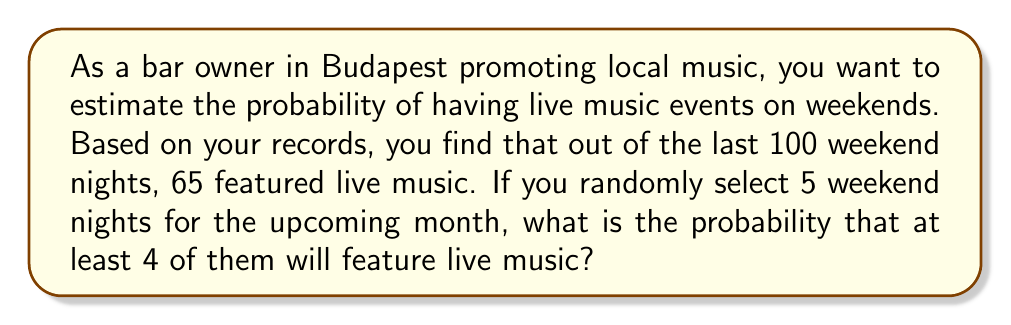What is the answer to this math problem? To solve this problem, we'll use the binomial probability distribution.

1. First, let's identify the components:
   - $n$ (number of trials) = 5 weekend nights
   - $p$ (probability of success) = 65/100 = 0.65
   - $q$ (probability of failure) = 1 - p = 0.35
   - We want the probability of at least 4 successes, so we'll calculate P(X ≥ 4)

2. The binomial probability formula is:

   $$P(X = k) = \binom{n}{k} p^k q^{n-k}$$

3. We need to calculate P(X = 4) + P(X = 5):

   $$P(X \geq 4) = P(X = 4) + P(X = 5)$$

4. Calculate P(X = 4):
   $$P(X = 4) = \binom{5}{4} (0.65)^4 (0.35)^1$$
   $$= 5 \cdot (0.65)^4 \cdot (0.35)$$
   $$= 5 \cdot 0.1785 \cdot 0.35$$
   $$= 0.3124$$

5. Calculate P(X = 5):
   $$P(X = 5) = \binom{5}{5} (0.65)^5 (0.35)^0$$
   $$= 1 \cdot (0.65)^5 \cdot 1$$
   $$= 0.1160$$

6. Sum the probabilities:
   $$P(X \geq 4) = P(X = 4) + P(X = 5)$$
   $$= 0.3124 + 0.1160$$
   $$= 0.4284$$
Answer: The probability that at least 4 out of 5 randomly selected weekend nights will feature live music is approximately 0.4284 or 42.84%. 